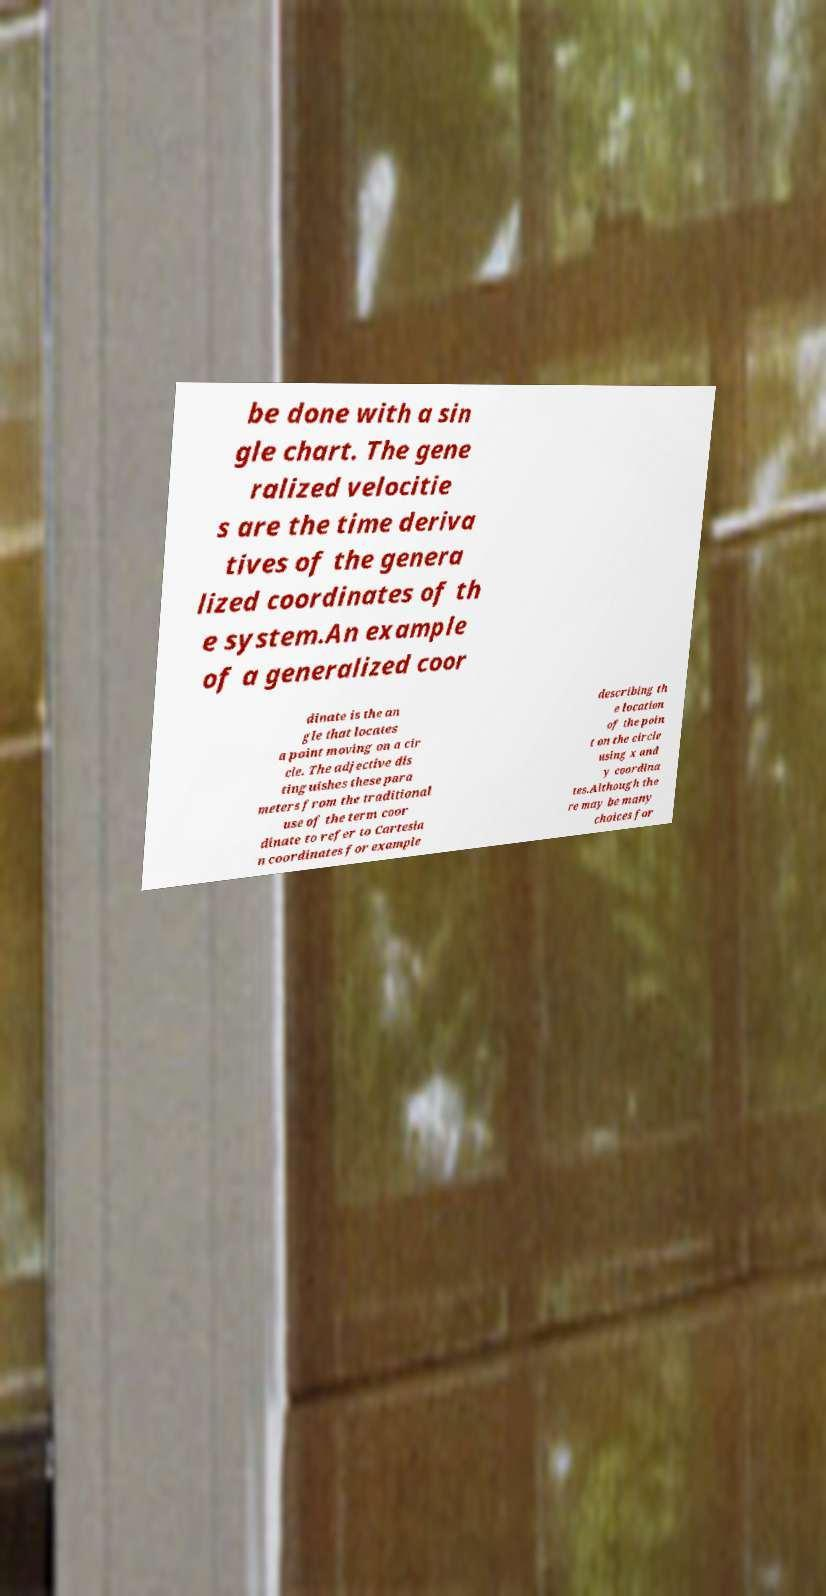Can you accurately transcribe the text from the provided image for me? be done with a sin gle chart. The gene ralized velocitie s are the time deriva tives of the genera lized coordinates of th e system.An example of a generalized coor dinate is the an gle that locates a point moving on a cir cle. The adjective dis tinguishes these para meters from the traditional use of the term coor dinate to refer to Cartesia n coordinates for example describing th e location of the poin t on the circle using x and y coordina tes.Although the re may be many choices for 